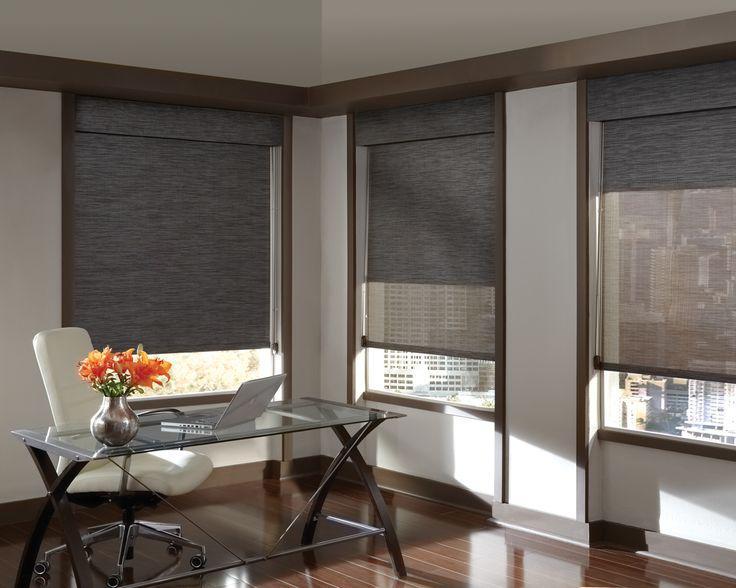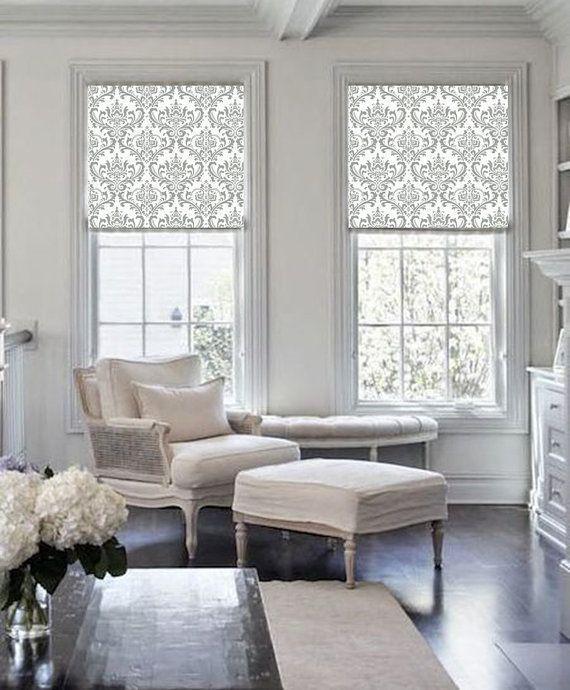The first image is the image on the left, the second image is the image on the right. Assess this claim about the two images: "There are five blinds.". Correct or not? Answer yes or no. Yes. The first image is the image on the left, the second image is the image on the right. Evaluate the accuracy of this statement regarding the images: "All the window shades are partially open.". Is it true? Answer yes or no. Yes. 